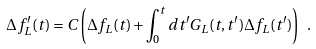Convert formula to latex. <formula><loc_0><loc_0><loc_500><loc_500>\Delta f ^ { \prime } _ { L } ( t ) = C \left ( \Delta f _ { L } ( t ) + \int _ { 0 } ^ { t } d t ^ { \prime } G _ { L } ( t , t ^ { \prime } ) \Delta f _ { L } ( t ^ { \prime } ) \right ) \ .</formula> 